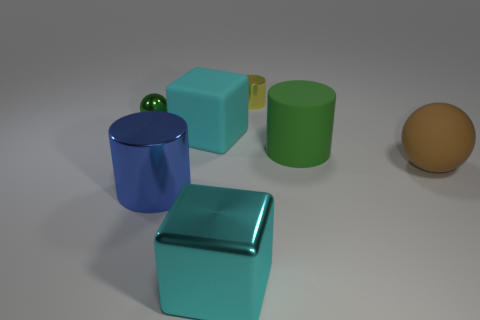There is a cyan cube right of the cyan rubber object; does it have the same size as the cyan block that is behind the large cyan metal thing?
Give a very brief answer. Yes. Are there the same number of big objects that are left of the small green object and large cyan metal cubes that are to the right of the small yellow object?
Make the answer very short. Yes. Is the size of the green rubber thing the same as the matte thing to the left of the yellow object?
Keep it short and to the point. Yes. There is a cyan cube that is on the right side of the block behind the shiny block; what is it made of?
Offer a very short reply. Metal. Are there an equal number of large green matte objects that are in front of the green matte thing and small cyan shiny objects?
Keep it short and to the point. Yes. There is a cylinder that is both left of the green cylinder and to the right of the blue thing; what is its size?
Keep it short and to the point. Small. There is a cube that is in front of the large rubber sphere that is right of the big cyan shiny block; what color is it?
Provide a short and direct response. Cyan. How many brown objects are either large cubes or big matte balls?
Offer a very short reply. 1. What color is the metallic object that is both behind the big green object and to the left of the yellow cylinder?
Make the answer very short. Green. What number of small objects are purple shiny spheres or cyan shiny things?
Offer a very short reply. 0. 